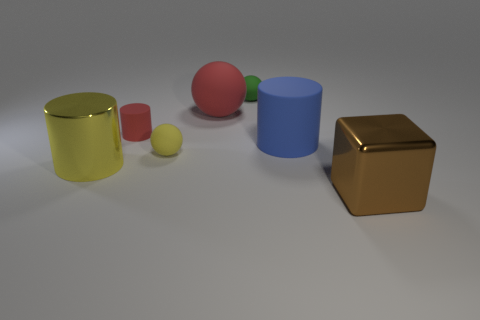What is the material of the tiny red thing that is the same shape as the blue matte object?
Your answer should be very brief. Rubber. There is a matte ball in front of the red sphere; is its color the same as the shiny cylinder?
Offer a terse response. Yes. Is the material of the brown thing the same as the object that is on the left side of the tiny red rubber object?
Give a very brief answer. Yes. There is a large shiny object behind the large brown object; what is its shape?
Your answer should be compact. Cylinder. What number of other objects are the same material as the red cylinder?
Your answer should be very brief. 4. How big is the green ball?
Offer a terse response. Small. What number of other things are the same color as the shiny cube?
Provide a succinct answer. 0. There is a large thing that is both in front of the big blue matte object and right of the tiny red rubber object; what is its color?
Provide a succinct answer. Brown. What number of large red things are there?
Your answer should be very brief. 1. Does the tiny green ball have the same material as the small cylinder?
Your response must be concise. Yes. 